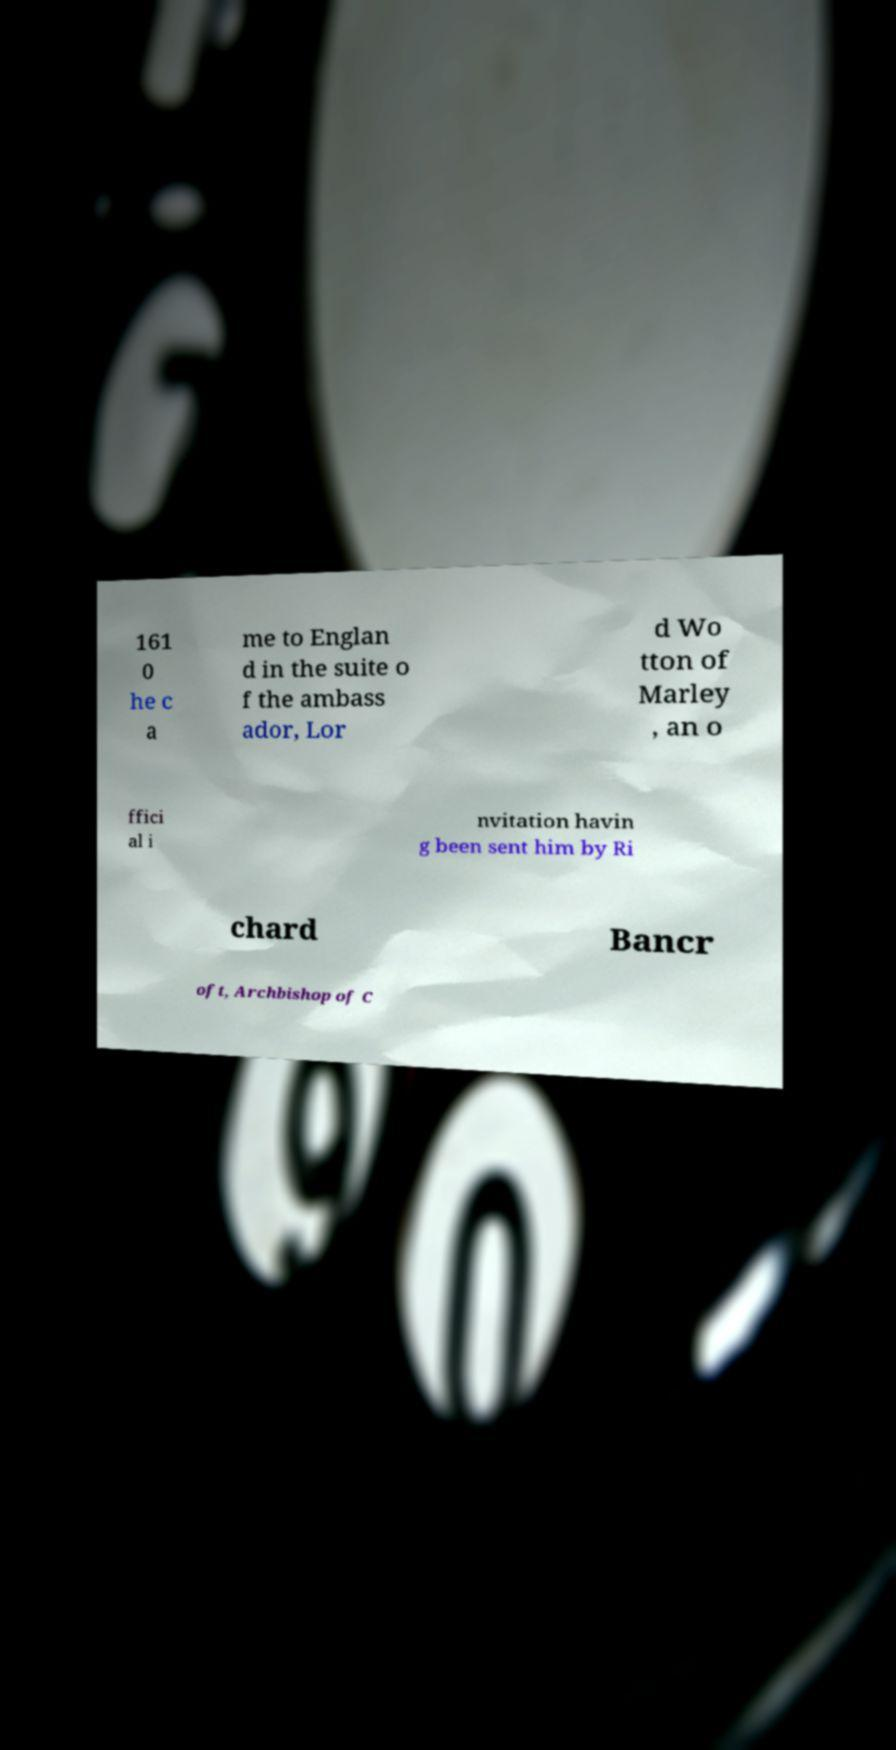For documentation purposes, I need the text within this image transcribed. Could you provide that? 161 0 he c a me to Englan d in the suite o f the ambass ador, Lor d Wo tton of Marley , an o ffici al i nvitation havin g been sent him by Ri chard Bancr oft, Archbishop of C 